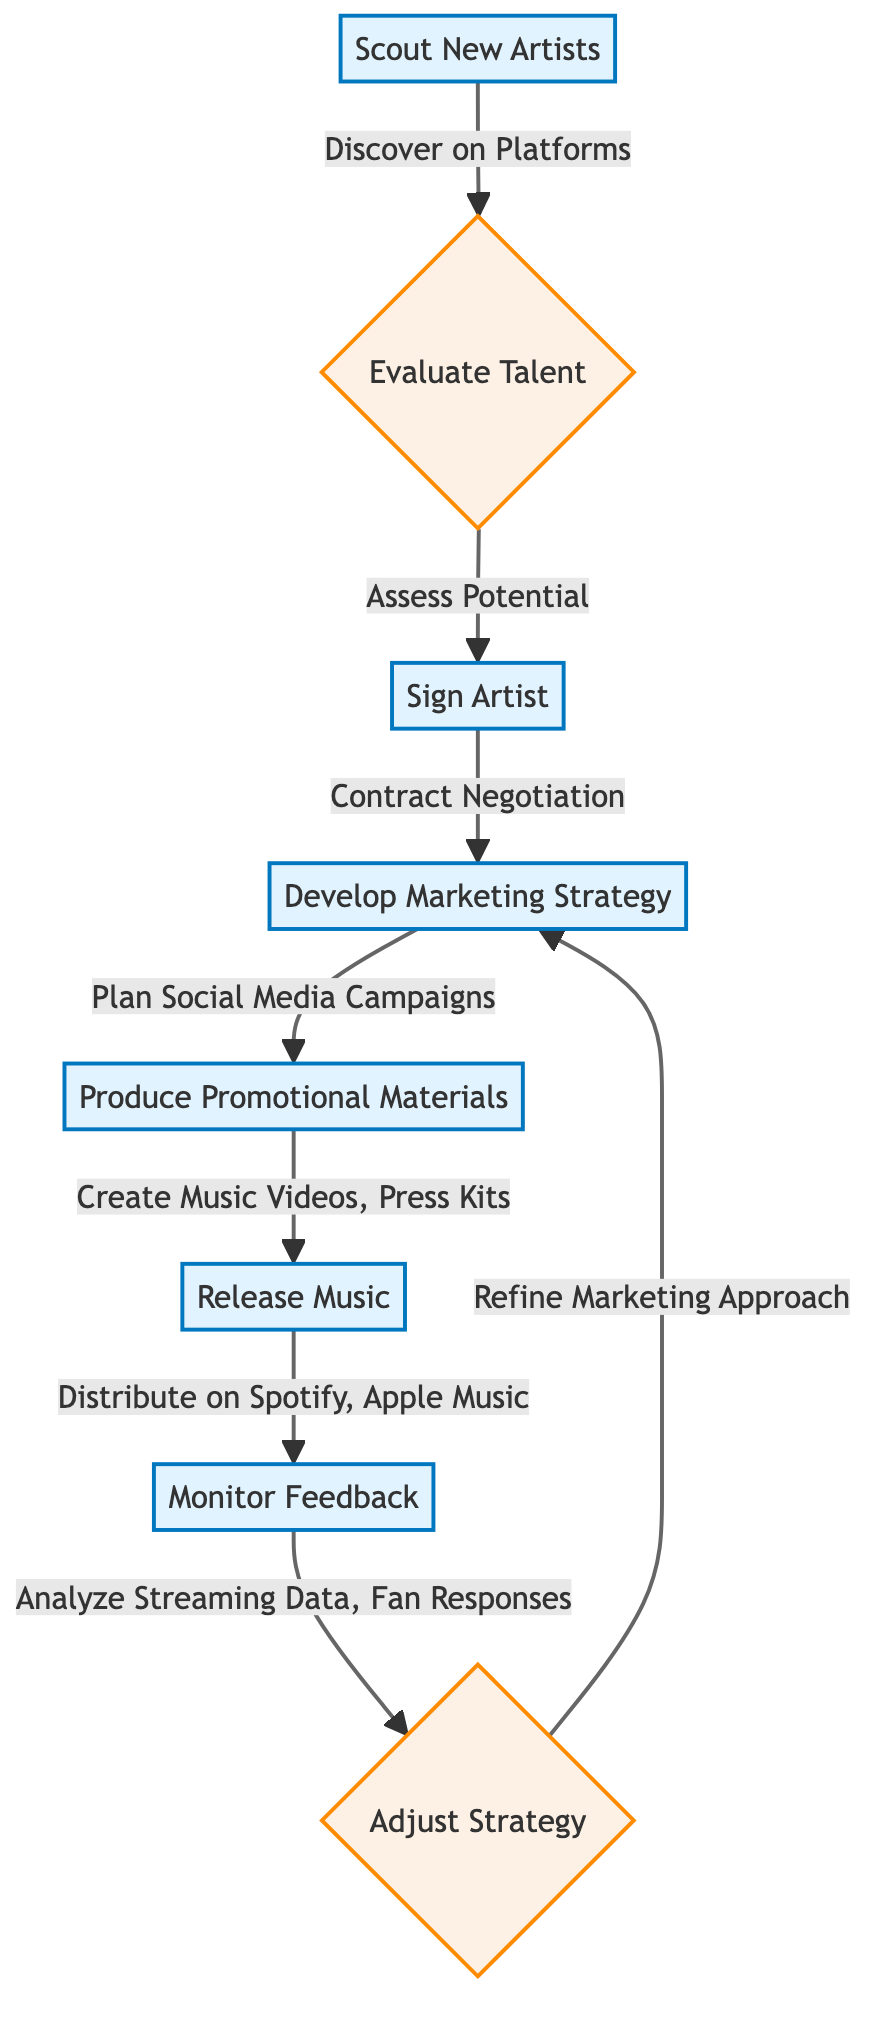What is the first step in the workflow? The first step is labeled as "Scout New Artists," which initiates the workflow of scouting, signing, and promoting new independent artists.
Answer: Scout New Artists How many decision nodes are in the diagram? The diagram contains two decision nodes, which are labeled "Evaluate Talent" and "Adjust Strategy."
Answer: 2 What do you do after releasing the music? After releasing the music, the next step is to "Monitor Feedback," which allows for the analysis of audience reception.
Answer: Monitor Feedback What is developed right after signing the artist? Right after signing the artist, the next step is to "Develop Marketing Strategy," which involves creating plans for promoting the artist.
Answer: Develop Marketing Strategy What happens if you need to adjust your strategy? If you need to adjust your strategy, the workflow indicates to "Refine Marketing Approach," which leads back to developing the marketing strategy once more.
Answer: Refine Marketing Approach How do you distribute the music? Music is distributed on platforms such as "Spotify" and "Apple Music," which are specified in the diagram for distribution channels.
Answer: Spotify, Apple Music What type of materials are produced after developing a marketing strategy? After developing a marketing strategy, the next step is to "Produce Promotional Materials," which includes creating various marketing resources.
Answer: Produce Promotional Materials What is the outcome of analyzing streaming data? Analyzing streaming data leads to the decision of whether to "Adjust Strategy," based on the responses collected from fans and the data obtained.
Answer: Adjust Strategy 